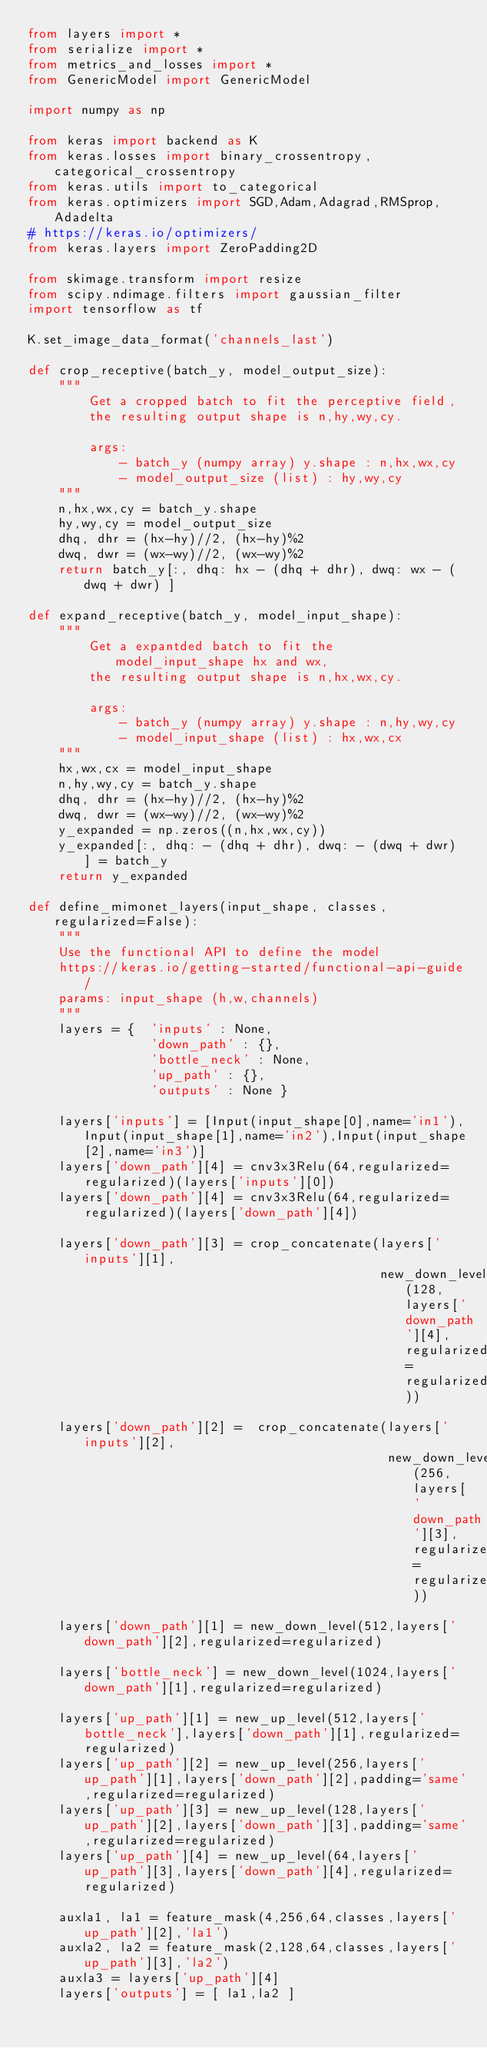Convert code to text. <code><loc_0><loc_0><loc_500><loc_500><_Python_>from layers import *
from serialize import *
from metrics_and_losses import *
from GenericModel import GenericModel

import numpy as np

from keras import backend as K
from keras.losses import binary_crossentropy, categorical_crossentropy
from keras.utils import to_categorical
from keras.optimizers import SGD,Adam,Adagrad,RMSprop,Adadelta
# https://keras.io/optimizers/
from keras.layers import ZeroPadding2D

from skimage.transform import resize
from scipy.ndimage.filters import gaussian_filter
import tensorflow as tf

K.set_image_data_format('channels_last')

def crop_receptive(batch_y, model_output_size):
    """
        Get a cropped batch to fit the perceptive field,
        the resulting output shape is n,hy,wy,cy.

        args:
            - batch_y (numpy array) y.shape : n,hx,wx,cy
            - model_output_size (list) : hy,wy,cy
    """
    n,hx,wx,cy = batch_y.shape
    hy,wy,cy = model_output_size
    dhq, dhr = (hx-hy)//2, (hx-hy)%2
    dwq, dwr = (wx-wy)//2, (wx-wy)%2
    return batch_y[:, dhq: hx - (dhq + dhr), dwq: wx - (dwq + dwr) ]

def expand_receptive(batch_y, model_input_shape):
    """
        Get a expantded batch to fit the model_input_shape hx and wx,
        the resulting output shape is n,hx,wx,cy.

        args:
            - batch_y (numpy array) y.shape : n,hy,wy,cy
            - model_input_shape (list) : hx,wx,cx
    """
    hx,wx,cx = model_input_shape
    n,hy,wy,cy = batch_y.shape
    dhq, dhr = (hx-hy)//2, (hx-hy)%2
    dwq, dwr = (wx-wy)//2, (wx-wy)%2
    y_expanded = np.zeros((n,hx,wx,cy))
    y_expanded[:, dhq: - (dhq + dhr), dwq: - (dwq + dwr) ] = batch_y
    return y_expanded

def define_mimonet_layers(input_shape, classes, regularized=False):
    """
    Use the functional API to define the model
    https://keras.io/getting-started/functional-api-guide/
    params: input_shape (h,w,channels)
    """
    layers = {  'inputs' : None,
                'down_path' : {},
                'bottle_neck' : None,
                'up_path' : {},
                'outputs' : None }

    layers['inputs'] = [Input(input_shape[0],name='in1'),Input(input_shape[1],name='in2'),Input(input_shape[2],name='in3')]
    layers['down_path'][4] = cnv3x3Relu(64,regularized=regularized)(layers['inputs'][0])
    layers['down_path'][4] = cnv3x3Relu(64,regularized=regularized)(layers['down_path'][4])
    
    layers['down_path'][3] = crop_concatenate(layers['inputs'][1], 
                                              new_down_level(128,layers['down_path'][4],regularized=regularized))
    
    layers['down_path'][2] =  crop_concatenate(layers['inputs'][2],
                                               new_down_level(256,layers['down_path'][3],regularized=regularized))
    
    layers['down_path'][1] = new_down_level(512,layers['down_path'][2],regularized=regularized)

    layers['bottle_neck'] = new_down_level(1024,layers['down_path'][1],regularized=regularized)

    layers['up_path'][1] = new_up_level(512,layers['bottle_neck'],layers['down_path'][1],regularized=regularized)
    layers['up_path'][2] = new_up_level(256,layers['up_path'][1],layers['down_path'][2],padding='same',regularized=regularized)
    layers['up_path'][3] = new_up_level(128,layers['up_path'][2],layers['down_path'][3],padding='same',regularized=regularized)
    layers['up_path'][4] = new_up_level(64,layers['up_path'][3],layers['down_path'][4],regularized=regularized)

    auxla1, la1 = feature_mask(4,256,64,classes,layers['up_path'][2],'la1')
    auxla2, la2 = feature_mask(2,128,64,classes,layers['up_path'][3],'la2')
    auxla3 = layers['up_path'][4]
    layers['outputs'] = [ la1,la2 ]</code> 